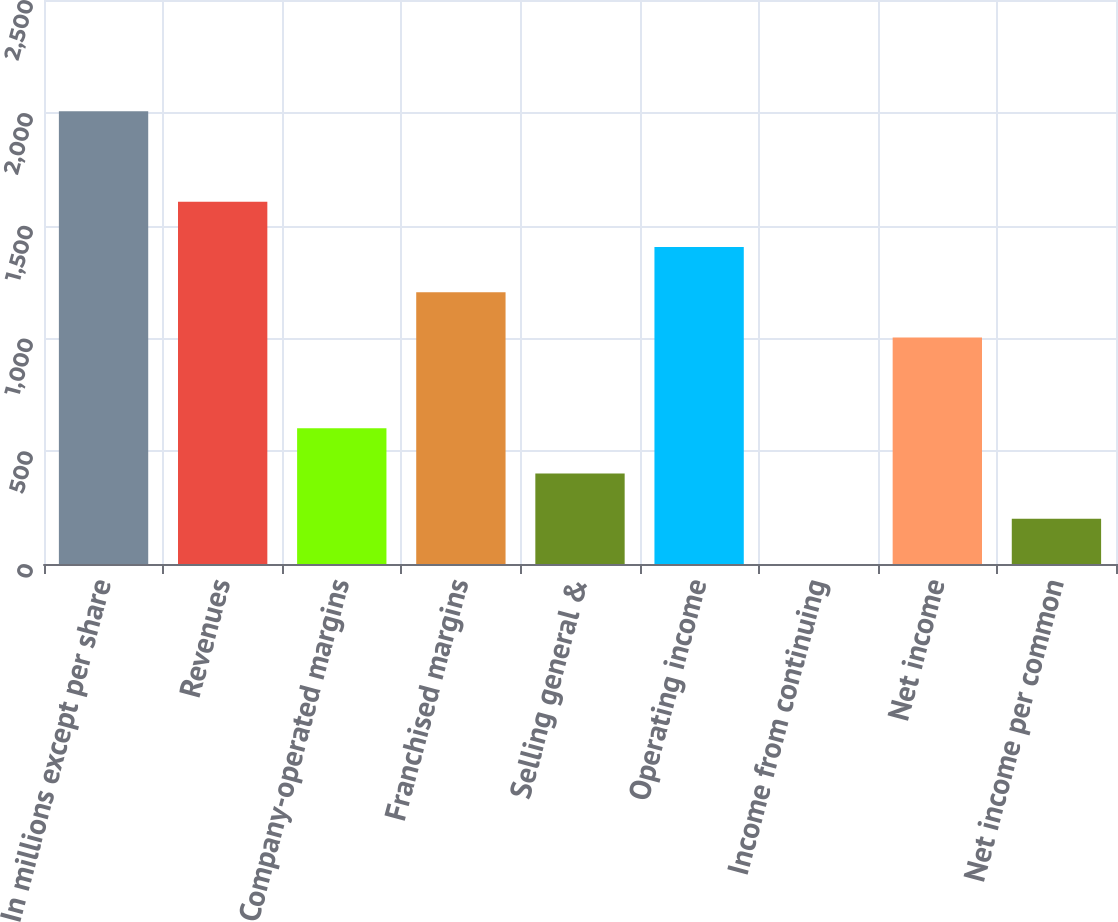Convert chart. <chart><loc_0><loc_0><loc_500><loc_500><bar_chart><fcel>In millions except per share<fcel>Revenues<fcel>Company-operated margins<fcel>Franchised margins<fcel>Selling general &<fcel>Operating income<fcel>Income from continuing<fcel>Net income<fcel>Net income per common<nl><fcel>2007<fcel>1605.64<fcel>602.19<fcel>1204.26<fcel>401.5<fcel>1404.95<fcel>0.12<fcel>1003.57<fcel>200.81<nl></chart> 